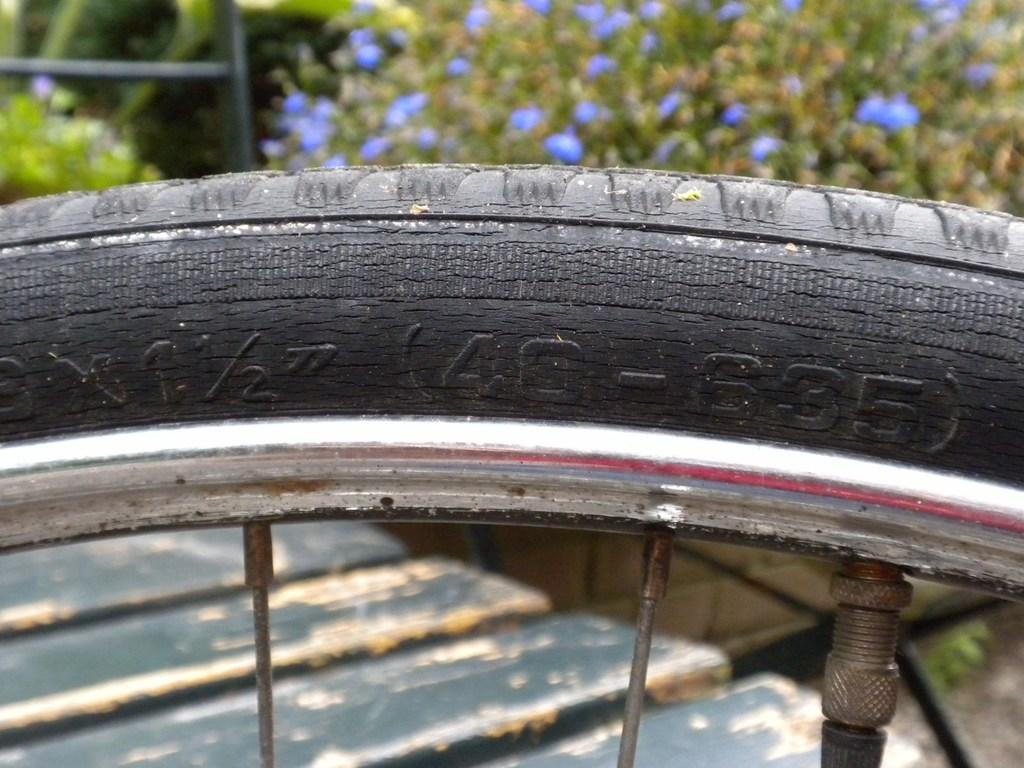Please provide a concise description of this image. In this image we can see cycle tube, cycle spokes and in the background of the image there are some trees and walkway which is in wooden color. 